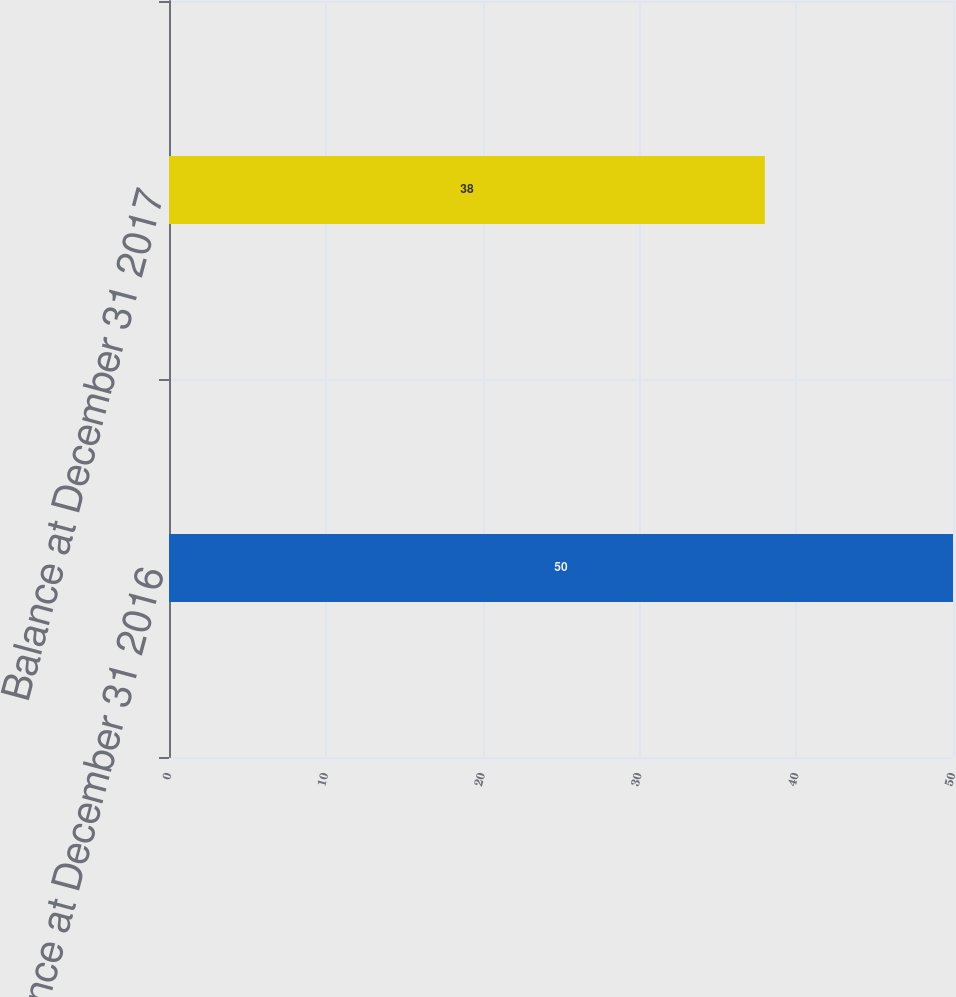Convert chart to OTSL. <chart><loc_0><loc_0><loc_500><loc_500><bar_chart><fcel>Balance at December 31 2016<fcel>Balance at December 31 2017<nl><fcel>50<fcel>38<nl></chart> 